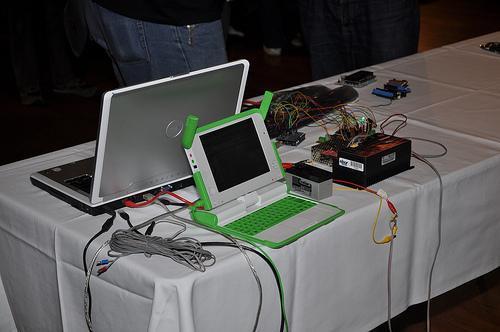How many laptops are there?
Give a very brief answer. 2. 